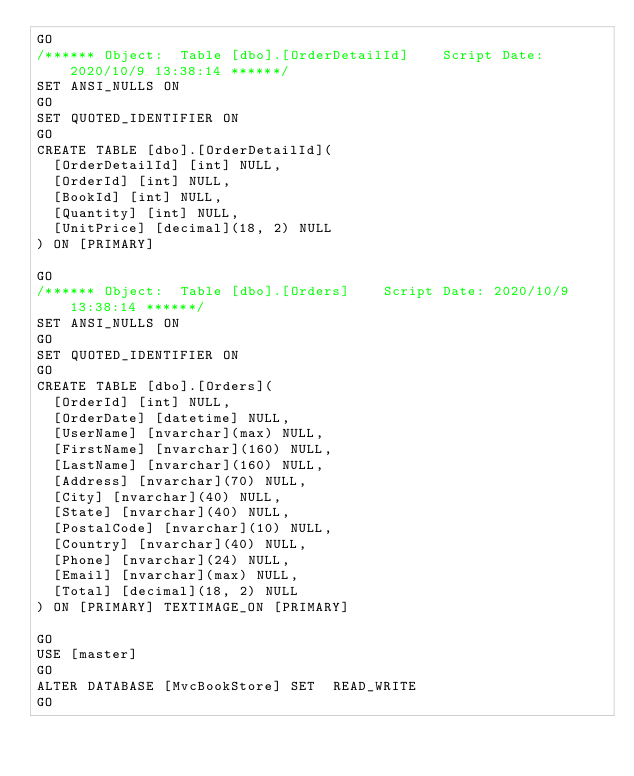Convert code to text. <code><loc_0><loc_0><loc_500><loc_500><_SQL_>GO
/****** Object:  Table [dbo].[OrderDetailId]    Script Date: 2020/10/9 13:38:14 ******/
SET ANSI_NULLS ON
GO
SET QUOTED_IDENTIFIER ON
GO
CREATE TABLE [dbo].[OrderDetailId](
	[OrderDetailId] [int] NULL,
	[OrderId] [int] NULL,
	[BookId] [int] NULL,
	[Quantity] [int] NULL,
	[UnitPrice] [decimal](18, 2) NULL
) ON [PRIMARY]

GO
/****** Object:  Table [dbo].[Orders]    Script Date: 2020/10/9 13:38:14 ******/
SET ANSI_NULLS ON
GO
SET QUOTED_IDENTIFIER ON
GO
CREATE TABLE [dbo].[Orders](
	[OrderId] [int] NULL,
	[OrderDate] [datetime] NULL,
	[UserName] [nvarchar](max) NULL,
	[FirstName] [nvarchar](160) NULL,
	[LastName] [nvarchar](160) NULL,
	[Address] [nvarchar](70) NULL,
	[City] [nvarchar](40) NULL,
	[State] [nvarchar](40) NULL,
	[PostalCode] [nvarchar](10) NULL,
	[Country] [nvarchar](40) NULL,
	[Phone] [nvarchar](24) NULL,
	[Email] [nvarchar](max) NULL,
	[Total] [decimal](18, 2) NULL
) ON [PRIMARY] TEXTIMAGE_ON [PRIMARY]

GO
USE [master]
GO
ALTER DATABASE [MvcBookStore] SET  READ_WRITE 
GO
</code> 